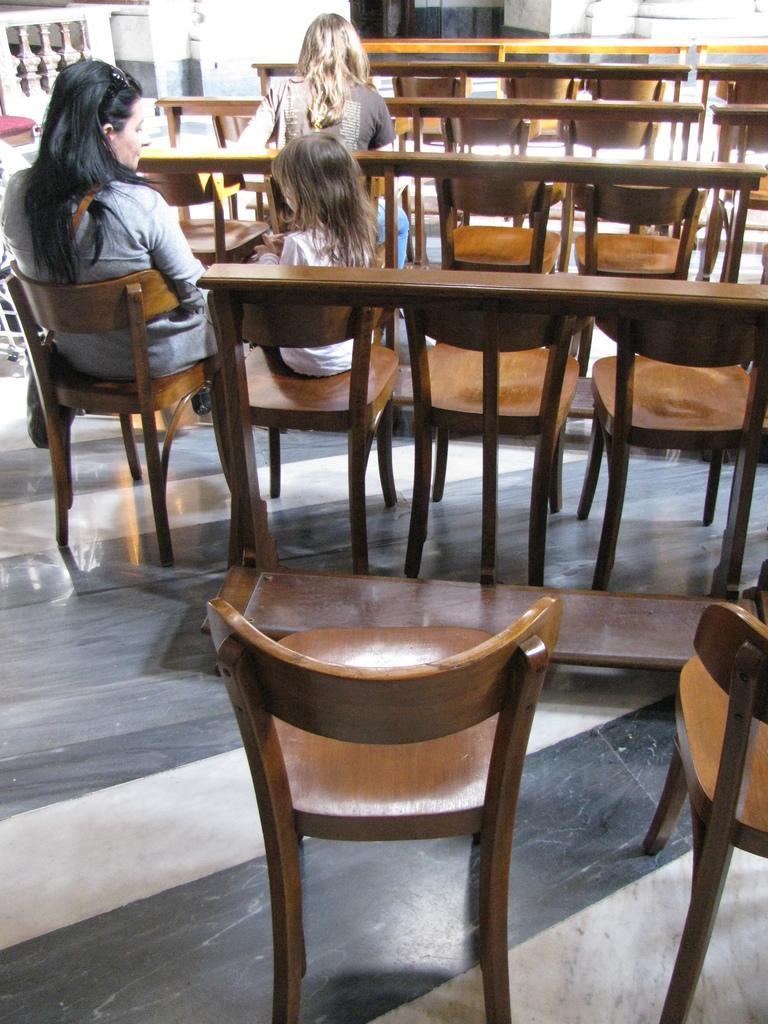Can you describe this image briefly? There are two women and a girl sitting in the chair. And there are some empty chairs in the given picture. In the background, there is a cement railing. 